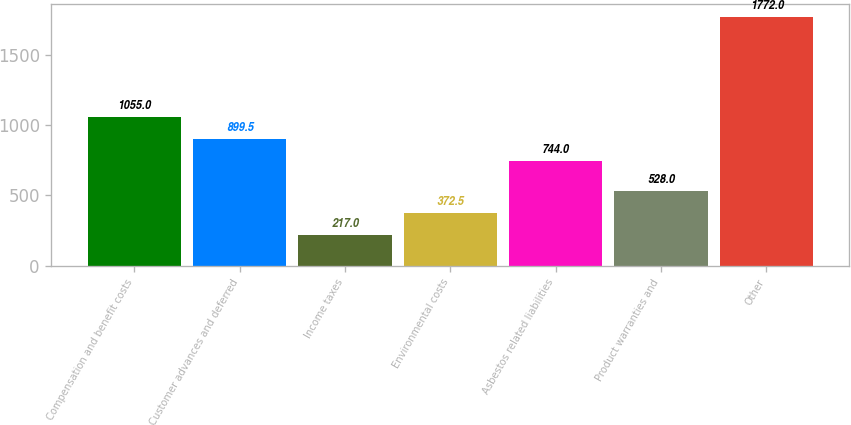<chart> <loc_0><loc_0><loc_500><loc_500><bar_chart><fcel>Compensation and benefit costs<fcel>Customer advances and deferred<fcel>Income taxes<fcel>Environmental costs<fcel>Asbestos related liabilities<fcel>Product warranties and<fcel>Other<nl><fcel>1055<fcel>899.5<fcel>217<fcel>372.5<fcel>744<fcel>528<fcel>1772<nl></chart> 